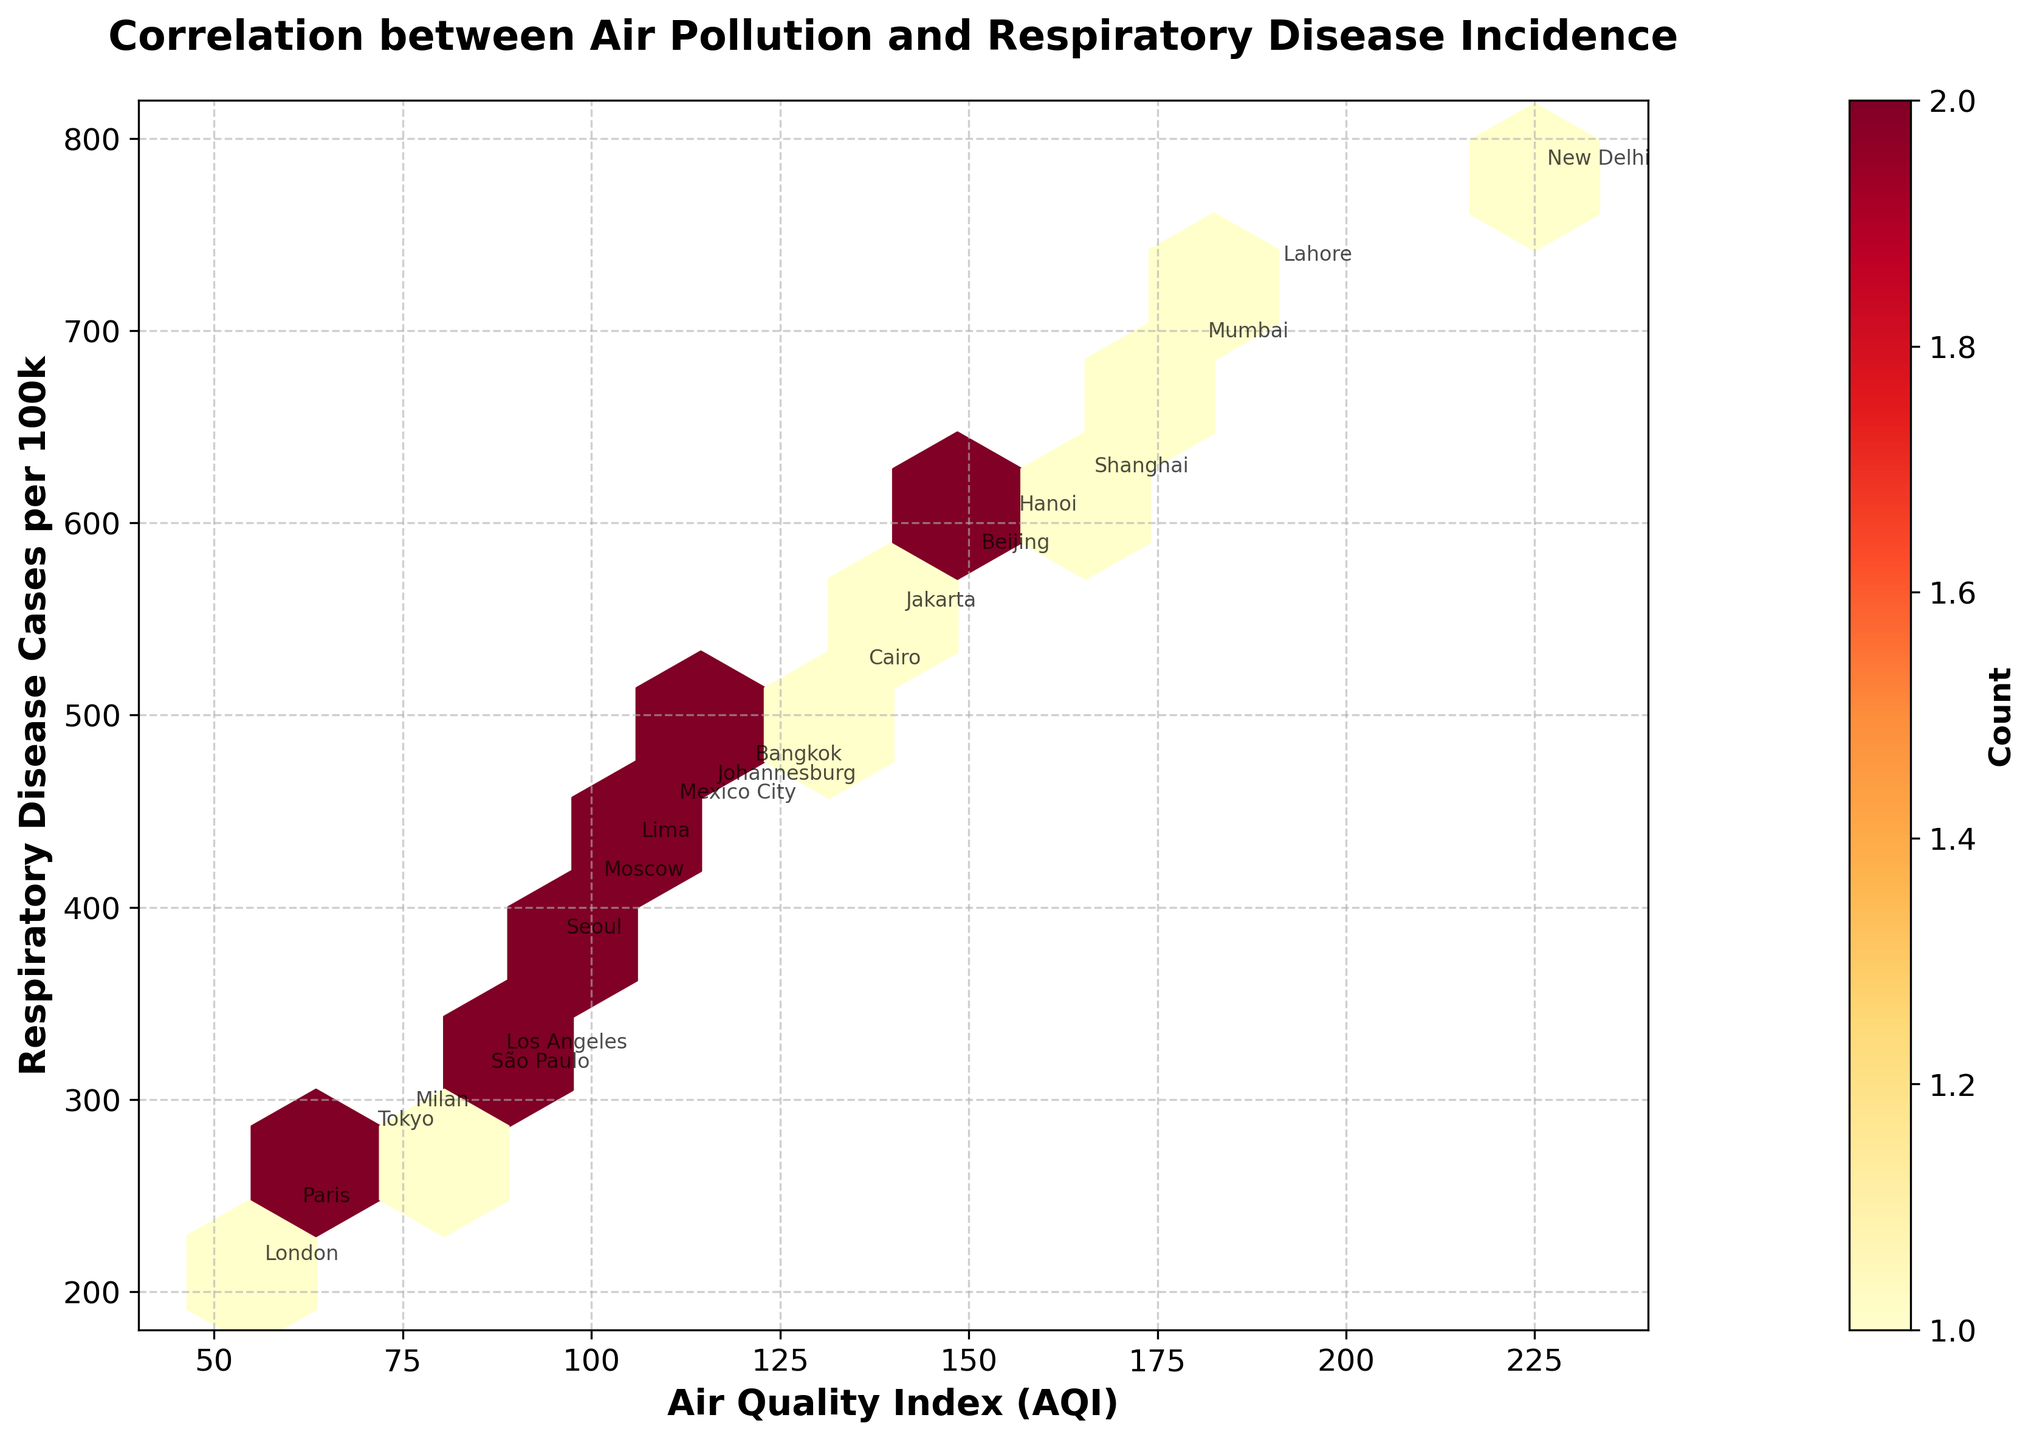What is the title of the plot? The title is located at the top of the figure, printed in bold and large font to make it easily noticeable.
Answer: Correlation between Air Pollution and Respiratory Disease Incidence What does the color in the hexbin plot represent? The color in the hexbin plot indicates the count of data points within each hexbin. This scale is depicted by the color bar on the right side of the plot.
Answer: Count of data points Which city has the highest Respiratory Disease Cases per 100k? By looking at the y-axis value and annotations, New Delhi has the highest value for Respiratory Disease Cases per 100k.
Answer: New Delhi What range is set for the x-axis (AQI)? The x-axis limits can be observed along the bottom, where the axis starts at 40 and ends at 240.
Answer: 40 to 240 How many cities have an AQI greater than 150? By examining the plot and annotations, the cities with AQI values greater than 150 are Beijing, New Delhi, Shanghai, Mumbai, Lahore, and Hanoi.
Answer: 6 What is the relationship between AQI and Respiratory Disease Cases per 100k? Observing the general trend in the hexbin plot, as the AQI increases, the number of Respiratory Disease Cases per 100k tends to increase as well, indicating a positive correlation.
Answer: Positive correlation Compare the Respiratory Disease Cases per 100k between Los Angeles and Seoul. From the annotations and y-axis, Los Angeles has 320 cases per 100k, while Seoul has 380 cases per 100k, meaning Seoul has higher Respiratory Disease Cases per 100k than Los Angeles.
Answer: Seoul has higher cases What is the general trend observed in the density of data points on the plot? Many data points are clustered in the middle regions, indicating that a majority of cities have moderate AQI and corresponding Respiratory Disease Cases per 100k.
Answer: Clustered around moderate values How is the data visually conveyed in this plot? The data is visualized using hexbin cells, where the count of data points is shown with varying colors within a hexagonal grid, along with individual annotations for each city.
Answer: Through hexbin cells with annotations What does the color bar indicate in the context of this hexbin plot? The color bar, positioned on the right side, shows different colors representing the count of data points within each hexbin cell. Darker colors represent higher counts.
Answer: Count of data points within hexbin cells 